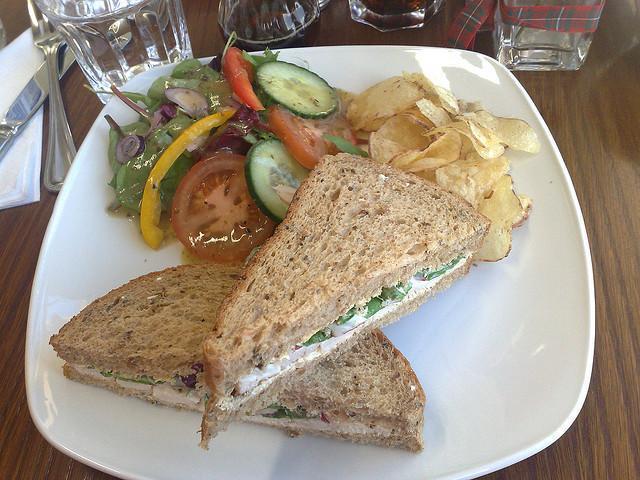How many pieces is the sandwich cut into?
Give a very brief answer. 2. How many sandwiches are there?
Give a very brief answer. 2. How many cups are there?
Give a very brief answer. 4. 